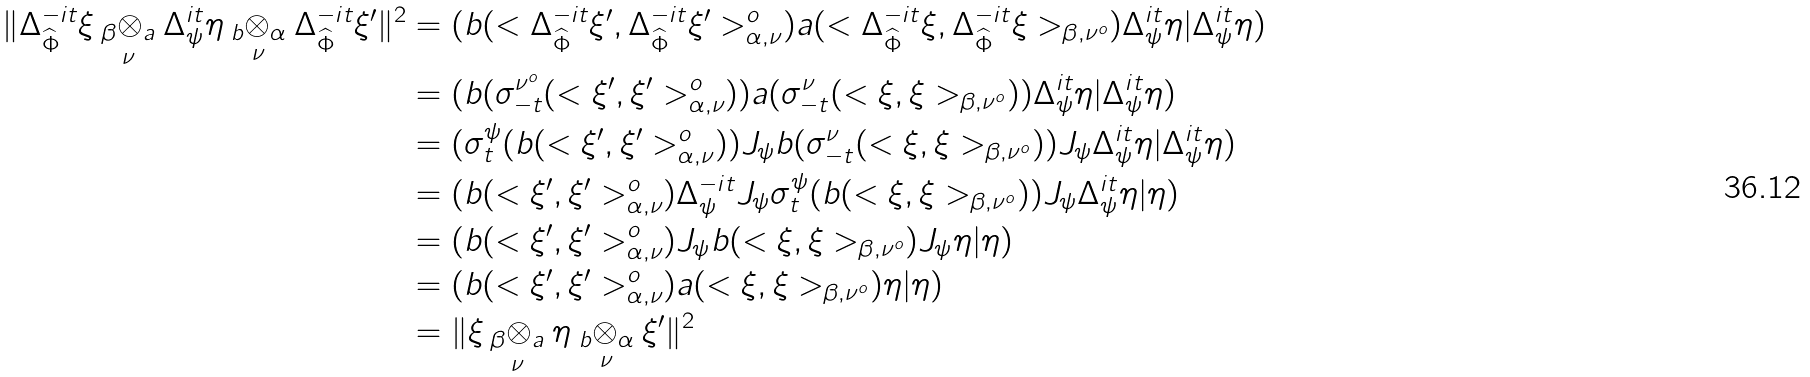Convert formula to latex. <formula><loc_0><loc_0><loc_500><loc_500>\| \Delta _ { \widehat { \Phi } } ^ { - i t } \xi \underset { \nu } { _ { \beta } \otimes _ { a } } \Delta _ { \psi } ^ { i t } \eta \underset { \nu } { _ { b } \otimes _ { \alpha } } \Delta _ { \widehat { \Phi } } ^ { - i t } \xi ^ { \prime } \| ^ { 2 } & = ( b ( < \Delta _ { \widehat { \Phi } } ^ { - i t } \xi ^ { \prime } , \Delta _ { \widehat { \Phi } } ^ { - i t } \xi ^ { \prime } > _ { \alpha , \nu } ^ { o } ) a ( < \Delta _ { \widehat { \Phi } } ^ { - i t } \xi , \Delta _ { \widehat { \Phi } } ^ { - i t } \xi > _ { \beta , \nu ^ { o } } ) \Delta _ { \psi } ^ { i t } \eta | \Delta _ { \psi } ^ { i t } \eta ) \\ & = ( b ( \sigma _ { - t } ^ { \nu ^ { o } } ( < \xi ^ { \prime } , \xi ^ { \prime } > _ { \alpha , \nu } ^ { o } ) ) a ( \sigma _ { - t } ^ { \nu } ( < \xi , \xi > _ { \beta , \nu ^ { o } } ) ) \Delta _ { \psi } ^ { i t } \eta | \Delta _ { \psi } ^ { i t } \eta ) \\ & = ( \sigma _ { t } ^ { \psi } ( b ( < \xi ^ { \prime } , \xi ^ { \prime } > _ { \alpha , \nu } ^ { o } ) ) J _ { \psi } b ( \sigma _ { - t } ^ { \nu } ( < \xi , \xi > _ { \beta , \nu ^ { o } } ) ) J _ { \psi } \Delta _ { \psi } ^ { i t } \eta | \Delta _ { \psi } ^ { i t } \eta ) \\ & = ( b ( < \xi ^ { \prime } , \xi ^ { \prime } > _ { \alpha , \nu } ^ { o } ) \Delta _ { \psi } ^ { - i t } J _ { \psi } \sigma _ { t } ^ { \psi } ( b ( < \xi , \xi > _ { \beta , \nu ^ { o } } ) ) J _ { \psi } \Delta _ { \psi } ^ { i t } \eta | \eta ) \\ & = ( b ( < \xi ^ { \prime } , \xi ^ { \prime } > _ { \alpha , \nu } ^ { o } ) J _ { \psi } b ( < \xi , \xi > _ { \beta , \nu ^ { o } } ) J _ { \psi } \eta | \eta ) \\ & = ( b ( < \xi ^ { \prime } , \xi ^ { \prime } > _ { \alpha , \nu } ^ { o } ) a ( < \xi , \xi > _ { \beta , \nu ^ { o } } ) \eta | \eta ) \\ & = \| \xi \underset { \nu } { _ { \beta } \otimes _ { a } } \eta \underset { \nu } { _ { b } \otimes _ { \alpha } } \xi ^ { \prime } \| ^ { 2 }</formula> 